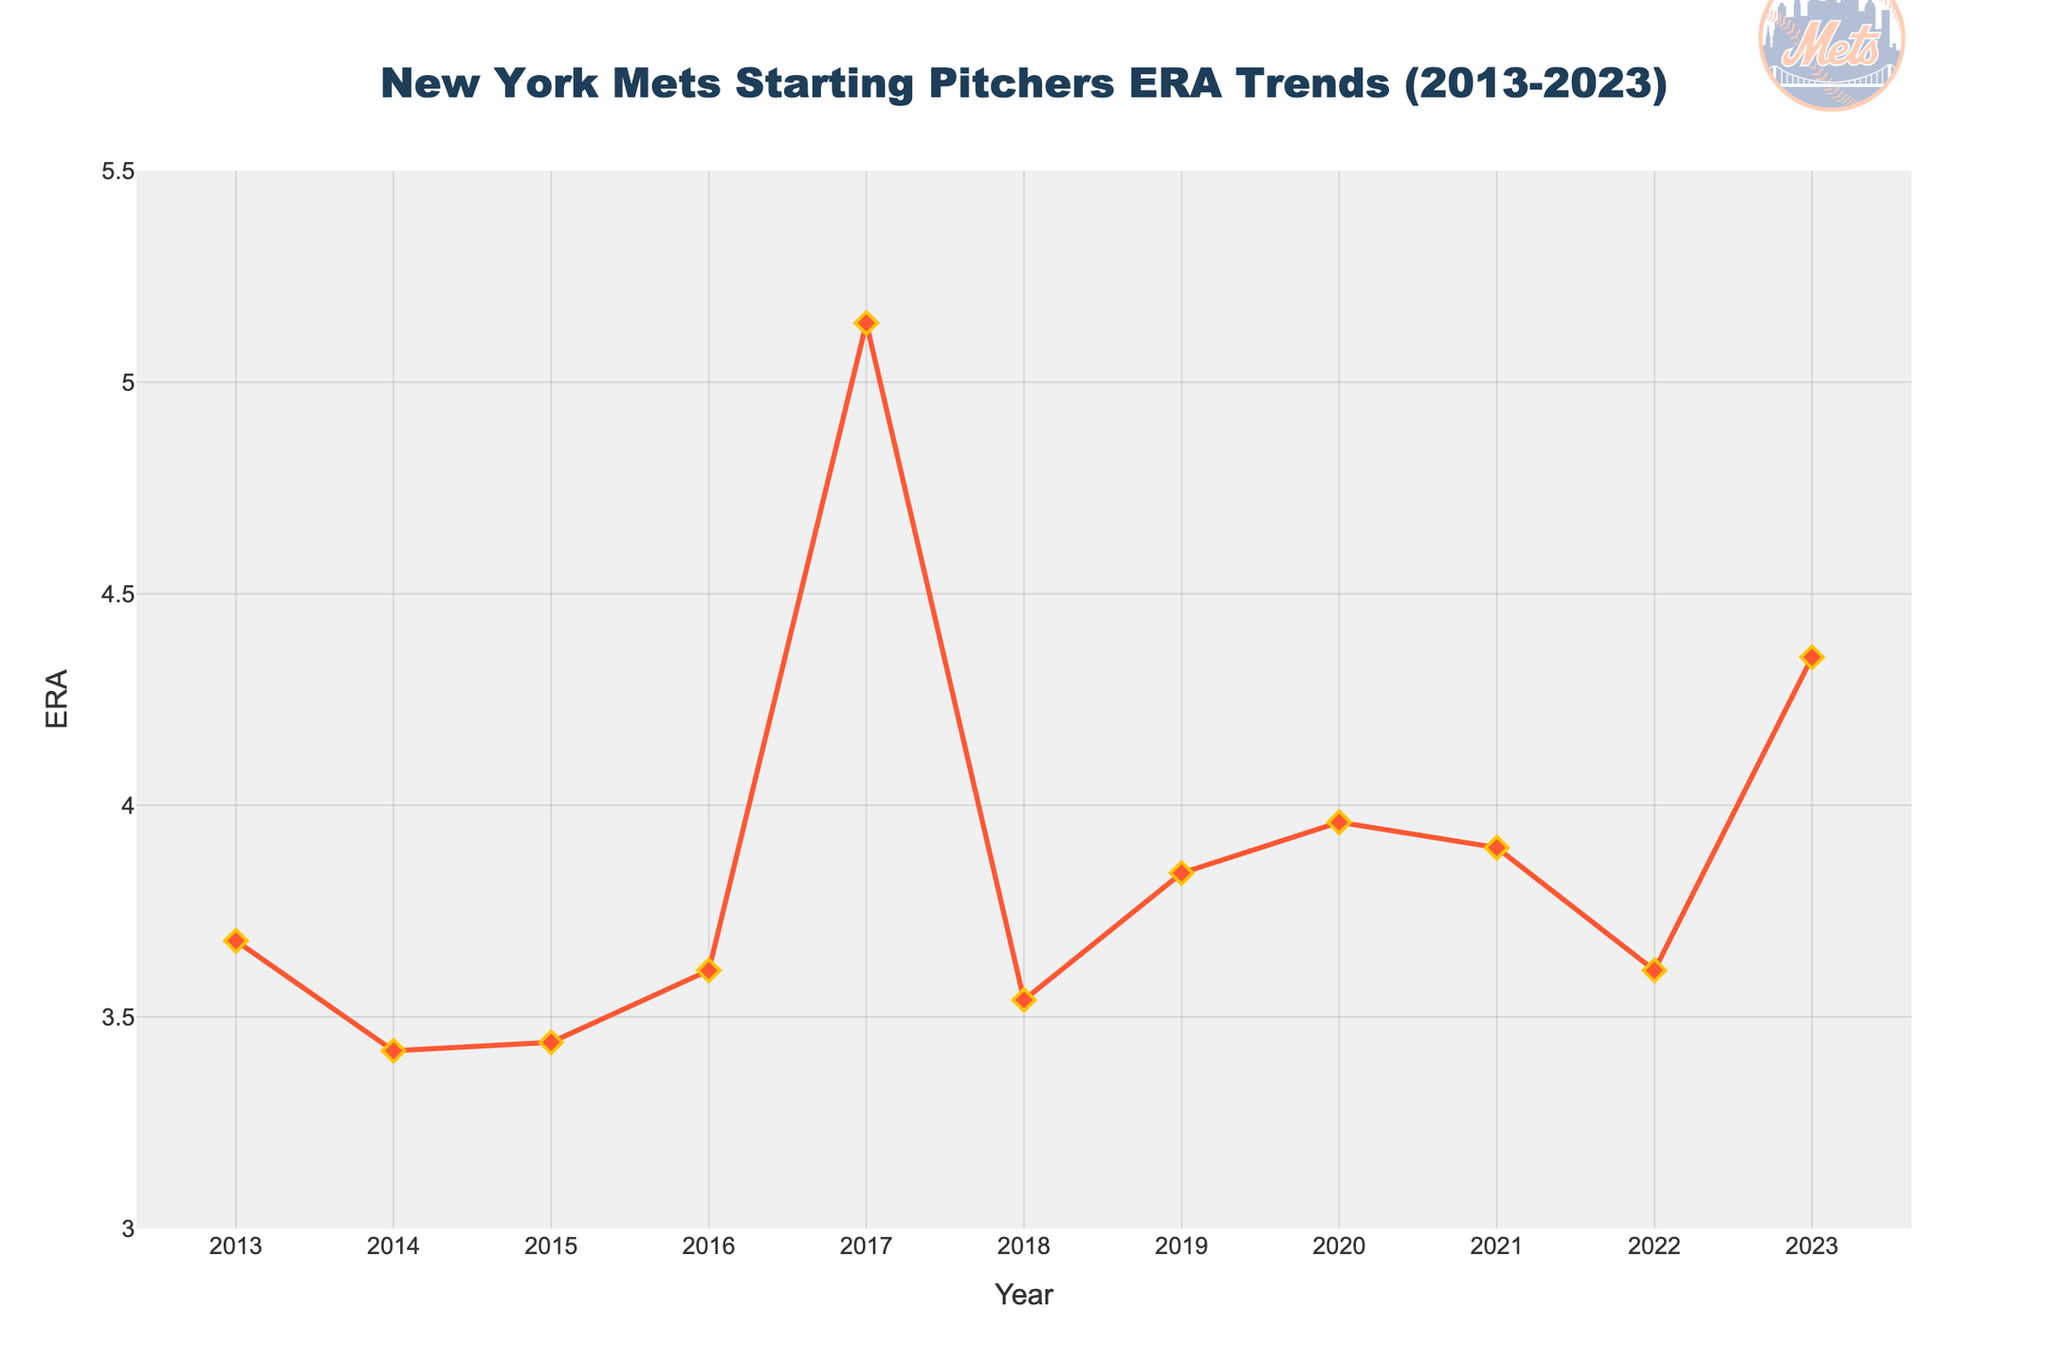Which year had the highest ERA? The highest value on the y-axis represents the highest ERA. In the chart, this peak corresponds to the year 2017.
Answer: 2017 Which year had the lowest ERA? The lowest value on the y-axis represents the lowest ERA. In the chart, this point is in 2014.
Answer: 2014 What has been the general trend of ERA from 2013 to 2023? To identify the trend, observe the direction of the line in the chart over the years. The ERA increased slightly over the decade but has fluctuations in between.
Answer: Slight increase with fluctuations How many years saw an ERA above 4.00? Count the years where the plotted ERA value exceeds 4.00. These are 2017 and 2023.
Answer: 2 By how much did the ERA increase comparing 2013 and 2023? Subtract the ERA of 2013 (3.68) from the ERA of 2023 (4.35).
Answer: 0.67 What was the average ERA over the decade? Sum all ERA values and divide by the number of years (11). (3.68 + 3.42 + 3.44 + 3.61 + 5.14 + 3.54 + 3.84 + 3.96 + 3.90 + 3.61 + 4.35) / 11 = 3.82 (approx).
Answer: 3.82 Which year had an ERA closest to 3.50? Looking at the chart, the year 2018 had an ERA closest to 3.50, specifically 3.54.
Answer: 2018 Which two consecutive years had the most significant change in ERA? Identify the two years with the greatest absolute difference in ERA. From the chart, the largest change happened between 2016 (3.61) and 2017 (5.14).
Answer: 2016-2017 By what percentage did the ERA change from 2014 to 2017? Calculate the percentage change using the formula [(ERA2017 - ERA2014) / ERA2014] * 100. [(5.14 - 3.42) / 3.42] * 100 = 50.29%.
Answer: 50.29% How does the ERA of 2022 compare to 2023? Look at the values for 2022 and 2023. The ERA increased from 3.61 in 2022 to 4.35 in 2023.
Answer: Increased 